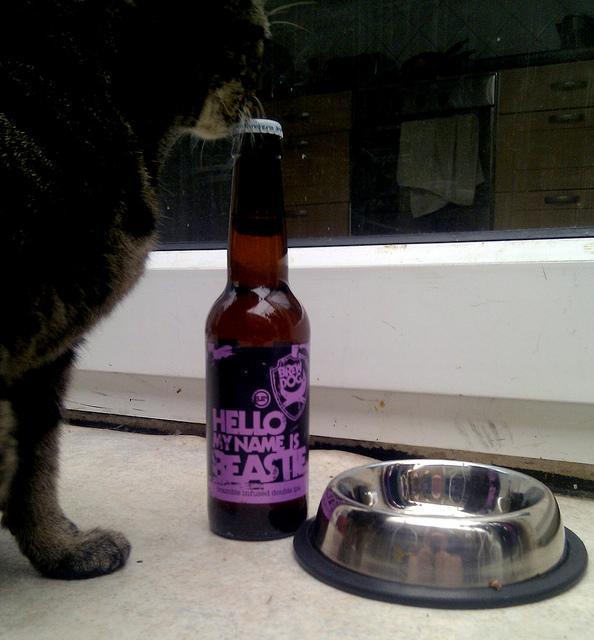How many horses are grazing on the hill?
Give a very brief answer. 0. 